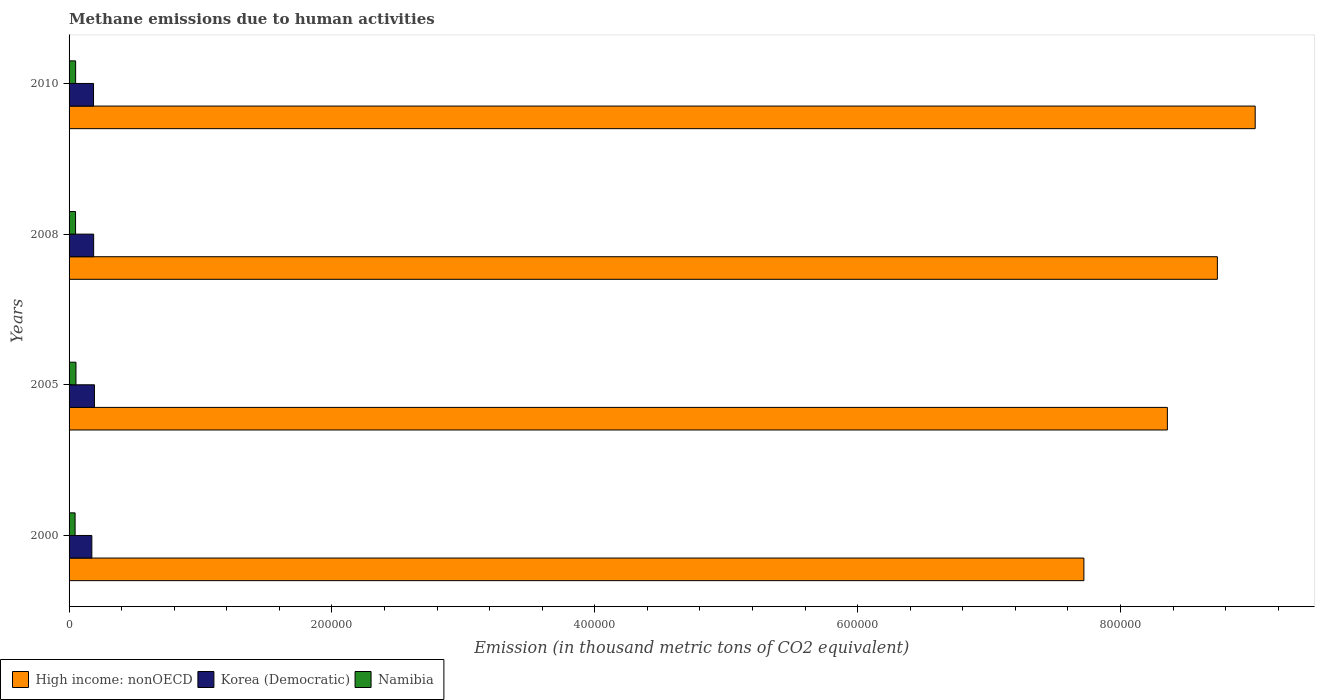Are the number of bars per tick equal to the number of legend labels?
Make the answer very short. Yes. What is the label of the 1st group of bars from the top?
Ensure brevity in your answer.  2010. In how many cases, is the number of bars for a given year not equal to the number of legend labels?
Ensure brevity in your answer.  0. What is the amount of methane emitted in Namibia in 2005?
Offer a very short reply. 5251.3. Across all years, what is the maximum amount of methane emitted in Korea (Democratic)?
Ensure brevity in your answer.  1.93e+04. Across all years, what is the minimum amount of methane emitted in High income: nonOECD?
Ensure brevity in your answer.  7.72e+05. In which year was the amount of methane emitted in Korea (Democratic) minimum?
Provide a short and direct response. 2000. What is the total amount of methane emitted in Korea (Democratic) in the graph?
Give a very brief answer. 7.39e+04. What is the difference between the amount of methane emitted in Korea (Democratic) in 2000 and that in 2010?
Offer a terse response. -1287.4. What is the difference between the amount of methane emitted in High income: nonOECD in 2000 and the amount of methane emitted in Namibia in 2008?
Make the answer very short. 7.67e+05. What is the average amount of methane emitted in Namibia per year?
Provide a succinct answer. 4940.77. In the year 2008, what is the difference between the amount of methane emitted in Korea (Democratic) and amount of methane emitted in Namibia?
Your answer should be very brief. 1.38e+04. What is the ratio of the amount of methane emitted in Korea (Democratic) in 2008 to that in 2010?
Ensure brevity in your answer.  1.01. Is the difference between the amount of methane emitted in Korea (Democratic) in 2000 and 2005 greater than the difference between the amount of methane emitted in Namibia in 2000 and 2005?
Provide a succinct answer. No. What is the difference between the highest and the second highest amount of methane emitted in Korea (Democratic)?
Your answer should be very brief. 596.3. What is the difference between the highest and the lowest amount of methane emitted in Namibia?
Give a very brief answer. 669.6. In how many years, is the amount of methane emitted in Namibia greater than the average amount of methane emitted in Namibia taken over all years?
Offer a terse response. 3. What does the 2nd bar from the top in 2005 represents?
Give a very brief answer. Korea (Democratic). What does the 2nd bar from the bottom in 2000 represents?
Give a very brief answer. Korea (Democratic). How many bars are there?
Offer a very short reply. 12. How many years are there in the graph?
Offer a terse response. 4. What is the difference between two consecutive major ticks on the X-axis?
Your response must be concise. 2.00e+05. Are the values on the major ticks of X-axis written in scientific E-notation?
Keep it short and to the point. No. Does the graph contain any zero values?
Provide a succinct answer. No. Does the graph contain grids?
Give a very brief answer. No. How many legend labels are there?
Offer a terse response. 3. What is the title of the graph?
Your response must be concise. Methane emissions due to human activities. Does "Colombia" appear as one of the legend labels in the graph?
Keep it short and to the point. No. What is the label or title of the X-axis?
Keep it short and to the point. Emission (in thousand metric tons of CO2 equivalent). What is the Emission (in thousand metric tons of CO2 equivalent) of High income: nonOECD in 2000?
Offer a very short reply. 7.72e+05. What is the Emission (in thousand metric tons of CO2 equivalent) in Korea (Democratic) in 2000?
Make the answer very short. 1.73e+04. What is the Emission (in thousand metric tons of CO2 equivalent) of Namibia in 2000?
Your answer should be very brief. 4581.7. What is the Emission (in thousand metric tons of CO2 equivalent) of High income: nonOECD in 2005?
Make the answer very short. 8.36e+05. What is the Emission (in thousand metric tons of CO2 equivalent) of Korea (Democratic) in 2005?
Make the answer very short. 1.93e+04. What is the Emission (in thousand metric tons of CO2 equivalent) of Namibia in 2005?
Your answer should be very brief. 5251.3. What is the Emission (in thousand metric tons of CO2 equivalent) of High income: nonOECD in 2008?
Provide a succinct answer. 8.74e+05. What is the Emission (in thousand metric tons of CO2 equivalent) in Korea (Democratic) in 2008?
Your answer should be very brief. 1.87e+04. What is the Emission (in thousand metric tons of CO2 equivalent) of Namibia in 2008?
Make the answer very short. 4941.9. What is the Emission (in thousand metric tons of CO2 equivalent) in High income: nonOECD in 2010?
Provide a succinct answer. 9.02e+05. What is the Emission (in thousand metric tons of CO2 equivalent) in Korea (Democratic) in 2010?
Provide a short and direct response. 1.86e+04. What is the Emission (in thousand metric tons of CO2 equivalent) in Namibia in 2010?
Your answer should be compact. 4988.2. Across all years, what is the maximum Emission (in thousand metric tons of CO2 equivalent) in High income: nonOECD?
Offer a terse response. 9.02e+05. Across all years, what is the maximum Emission (in thousand metric tons of CO2 equivalent) of Korea (Democratic)?
Provide a succinct answer. 1.93e+04. Across all years, what is the maximum Emission (in thousand metric tons of CO2 equivalent) of Namibia?
Your answer should be very brief. 5251.3. Across all years, what is the minimum Emission (in thousand metric tons of CO2 equivalent) in High income: nonOECD?
Your answer should be compact. 7.72e+05. Across all years, what is the minimum Emission (in thousand metric tons of CO2 equivalent) in Korea (Democratic)?
Your response must be concise. 1.73e+04. Across all years, what is the minimum Emission (in thousand metric tons of CO2 equivalent) of Namibia?
Your answer should be compact. 4581.7. What is the total Emission (in thousand metric tons of CO2 equivalent) of High income: nonOECD in the graph?
Provide a succinct answer. 3.38e+06. What is the total Emission (in thousand metric tons of CO2 equivalent) of Korea (Democratic) in the graph?
Provide a succinct answer. 7.39e+04. What is the total Emission (in thousand metric tons of CO2 equivalent) of Namibia in the graph?
Offer a terse response. 1.98e+04. What is the difference between the Emission (in thousand metric tons of CO2 equivalent) of High income: nonOECD in 2000 and that in 2005?
Your answer should be very brief. -6.35e+04. What is the difference between the Emission (in thousand metric tons of CO2 equivalent) of Korea (Democratic) in 2000 and that in 2005?
Your answer should be compact. -1977. What is the difference between the Emission (in thousand metric tons of CO2 equivalent) in Namibia in 2000 and that in 2005?
Your answer should be compact. -669.6. What is the difference between the Emission (in thousand metric tons of CO2 equivalent) of High income: nonOECD in 2000 and that in 2008?
Ensure brevity in your answer.  -1.02e+05. What is the difference between the Emission (in thousand metric tons of CO2 equivalent) of Korea (Democratic) in 2000 and that in 2008?
Your answer should be compact. -1380.7. What is the difference between the Emission (in thousand metric tons of CO2 equivalent) in Namibia in 2000 and that in 2008?
Your response must be concise. -360.2. What is the difference between the Emission (in thousand metric tons of CO2 equivalent) of High income: nonOECD in 2000 and that in 2010?
Your answer should be very brief. -1.30e+05. What is the difference between the Emission (in thousand metric tons of CO2 equivalent) of Korea (Democratic) in 2000 and that in 2010?
Make the answer very short. -1287.4. What is the difference between the Emission (in thousand metric tons of CO2 equivalent) in Namibia in 2000 and that in 2010?
Make the answer very short. -406.5. What is the difference between the Emission (in thousand metric tons of CO2 equivalent) in High income: nonOECD in 2005 and that in 2008?
Provide a succinct answer. -3.80e+04. What is the difference between the Emission (in thousand metric tons of CO2 equivalent) in Korea (Democratic) in 2005 and that in 2008?
Ensure brevity in your answer.  596.3. What is the difference between the Emission (in thousand metric tons of CO2 equivalent) in Namibia in 2005 and that in 2008?
Your response must be concise. 309.4. What is the difference between the Emission (in thousand metric tons of CO2 equivalent) of High income: nonOECD in 2005 and that in 2010?
Your answer should be very brief. -6.68e+04. What is the difference between the Emission (in thousand metric tons of CO2 equivalent) of Korea (Democratic) in 2005 and that in 2010?
Provide a short and direct response. 689.6. What is the difference between the Emission (in thousand metric tons of CO2 equivalent) in Namibia in 2005 and that in 2010?
Make the answer very short. 263.1. What is the difference between the Emission (in thousand metric tons of CO2 equivalent) in High income: nonOECD in 2008 and that in 2010?
Ensure brevity in your answer.  -2.88e+04. What is the difference between the Emission (in thousand metric tons of CO2 equivalent) in Korea (Democratic) in 2008 and that in 2010?
Your response must be concise. 93.3. What is the difference between the Emission (in thousand metric tons of CO2 equivalent) in Namibia in 2008 and that in 2010?
Provide a succinct answer. -46.3. What is the difference between the Emission (in thousand metric tons of CO2 equivalent) in High income: nonOECD in 2000 and the Emission (in thousand metric tons of CO2 equivalent) in Korea (Democratic) in 2005?
Ensure brevity in your answer.  7.53e+05. What is the difference between the Emission (in thousand metric tons of CO2 equivalent) in High income: nonOECD in 2000 and the Emission (in thousand metric tons of CO2 equivalent) in Namibia in 2005?
Your answer should be very brief. 7.67e+05. What is the difference between the Emission (in thousand metric tons of CO2 equivalent) in Korea (Democratic) in 2000 and the Emission (in thousand metric tons of CO2 equivalent) in Namibia in 2005?
Offer a terse response. 1.21e+04. What is the difference between the Emission (in thousand metric tons of CO2 equivalent) of High income: nonOECD in 2000 and the Emission (in thousand metric tons of CO2 equivalent) of Korea (Democratic) in 2008?
Your response must be concise. 7.53e+05. What is the difference between the Emission (in thousand metric tons of CO2 equivalent) in High income: nonOECD in 2000 and the Emission (in thousand metric tons of CO2 equivalent) in Namibia in 2008?
Provide a short and direct response. 7.67e+05. What is the difference between the Emission (in thousand metric tons of CO2 equivalent) in Korea (Democratic) in 2000 and the Emission (in thousand metric tons of CO2 equivalent) in Namibia in 2008?
Your response must be concise. 1.24e+04. What is the difference between the Emission (in thousand metric tons of CO2 equivalent) of High income: nonOECD in 2000 and the Emission (in thousand metric tons of CO2 equivalent) of Korea (Democratic) in 2010?
Your answer should be compact. 7.54e+05. What is the difference between the Emission (in thousand metric tons of CO2 equivalent) in High income: nonOECD in 2000 and the Emission (in thousand metric tons of CO2 equivalent) in Namibia in 2010?
Offer a terse response. 7.67e+05. What is the difference between the Emission (in thousand metric tons of CO2 equivalent) of Korea (Democratic) in 2000 and the Emission (in thousand metric tons of CO2 equivalent) of Namibia in 2010?
Make the answer very short. 1.23e+04. What is the difference between the Emission (in thousand metric tons of CO2 equivalent) of High income: nonOECD in 2005 and the Emission (in thousand metric tons of CO2 equivalent) of Korea (Democratic) in 2008?
Keep it short and to the point. 8.17e+05. What is the difference between the Emission (in thousand metric tons of CO2 equivalent) in High income: nonOECD in 2005 and the Emission (in thousand metric tons of CO2 equivalent) in Namibia in 2008?
Make the answer very short. 8.31e+05. What is the difference between the Emission (in thousand metric tons of CO2 equivalent) in Korea (Democratic) in 2005 and the Emission (in thousand metric tons of CO2 equivalent) in Namibia in 2008?
Keep it short and to the point. 1.44e+04. What is the difference between the Emission (in thousand metric tons of CO2 equivalent) in High income: nonOECD in 2005 and the Emission (in thousand metric tons of CO2 equivalent) in Korea (Democratic) in 2010?
Keep it short and to the point. 8.17e+05. What is the difference between the Emission (in thousand metric tons of CO2 equivalent) in High income: nonOECD in 2005 and the Emission (in thousand metric tons of CO2 equivalent) in Namibia in 2010?
Your answer should be very brief. 8.31e+05. What is the difference between the Emission (in thousand metric tons of CO2 equivalent) of Korea (Democratic) in 2005 and the Emission (in thousand metric tons of CO2 equivalent) of Namibia in 2010?
Your answer should be very brief. 1.43e+04. What is the difference between the Emission (in thousand metric tons of CO2 equivalent) in High income: nonOECD in 2008 and the Emission (in thousand metric tons of CO2 equivalent) in Korea (Democratic) in 2010?
Provide a short and direct response. 8.55e+05. What is the difference between the Emission (in thousand metric tons of CO2 equivalent) in High income: nonOECD in 2008 and the Emission (in thousand metric tons of CO2 equivalent) in Namibia in 2010?
Offer a very short reply. 8.69e+05. What is the difference between the Emission (in thousand metric tons of CO2 equivalent) of Korea (Democratic) in 2008 and the Emission (in thousand metric tons of CO2 equivalent) of Namibia in 2010?
Your response must be concise. 1.37e+04. What is the average Emission (in thousand metric tons of CO2 equivalent) in High income: nonOECD per year?
Provide a short and direct response. 8.46e+05. What is the average Emission (in thousand metric tons of CO2 equivalent) in Korea (Democratic) per year?
Keep it short and to the point. 1.85e+04. What is the average Emission (in thousand metric tons of CO2 equivalent) in Namibia per year?
Provide a short and direct response. 4940.77. In the year 2000, what is the difference between the Emission (in thousand metric tons of CO2 equivalent) of High income: nonOECD and Emission (in thousand metric tons of CO2 equivalent) of Korea (Democratic)?
Make the answer very short. 7.55e+05. In the year 2000, what is the difference between the Emission (in thousand metric tons of CO2 equivalent) in High income: nonOECD and Emission (in thousand metric tons of CO2 equivalent) in Namibia?
Your response must be concise. 7.68e+05. In the year 2000, what is the difference between the Emission (in thousand metric tons of CO2 equivalent) of Korea (Democratic) and Emission (in thousand metric tons of CO2 equivalent) of Namibia?
Provide a short and direct response. 1.27e+04. In the year 2005, what is the difference between the Emission (in thousand metric tons of CO2 equivalent) of High income: nonOECD and Emission (in thousand metric tons of CO2 equivalent) of Korea (Democratic)?
Make the answer very short. 8.16e+05. In the year 2005, what is the difference between the Emission (in thousand metric tons of CO2 equivalent) of High income: nonOECD and Emission (in thousand metric tons of CO2 equivalent) of Namibia?
Provide a succinct answer. 8.30e+05. In the year 2005, what is the difference between the Emission (in thousand metric tons of CO2 equivalent) of Korea (Democratic) and Emission (in thousand metric tons of CO2 equivalent) of Namibia?
Offer a terse response. 1.40e+04. In the year 2008, what is the difference between the Emission (in thousand metric tons of CO2 equivalent) of High income: nonOECD and Emission (in thousand metric tons of CO2 equivalent) of Korea (Democratic)?
Ensure brevity in your answer.  8.55e+05. In the year 2008, what is the difference between the Emission (in thousand metric tons of CO2 equivalent) of High income: nonOECD and Emission (in thousand metric tons of CO2 equivalent) of Namibia?
Keep it short and to the point. 8.69e+05. In the year 2008, what is the difference between the Emission (in thousand metric tons of CO2 equivalent) of Korea (Democratic) and Emission (in thousand metric tons of CO2 equivalent) of Namibia?
Ensure brevity in your answer.  1.38e+04. In the year 2010, what is the difference between the Emission (in thousand metric tons of CO2 equivalent) in High income: nonOECD and Emission (in thousand metric tons of CO2 equivalent) in Korea (Democratic)?
Your response must be concise. 8.84e+05. In the year 2010, what is the difference between the Emission (in thousand metric tons of CO2 equivalent) in High income: nonOECD and Emission (in thousand metric tons of CO2 equivalent) in Namibia?
Offer a very short reply. 8.97e+05. In the year 2010, what is the difference between the Emission (in thousand metric tons of CO2 equivalent) of Korea (Democratic) and Emission (in thousand metric tons of CO2 equivalent) of Namibia?
Your response must be concise. 1.36e+04. What is the ratio of the Emission (in thousand metric tons of CO2 equivalent) of High income: nonOECD in 2000 to that in 2005?
Your answer should be very brief. 0.92. What is the ratio of the Emission (in thousand metric tons of CO2 equivalent) of Korea (Democratic) in 2000 to that in 2005?
Make the answer very short. 0.9. What is the ratio of the Emission (in thousand metric tons of CO2 equivalent) of Namibia in 2000 to that in 2005?
Give a very brief answer. 0.87. What is the ratio of the Emission (in thousand metric tons of CO2 equivalent) of High income: nonOECD in 2000 to that in 2008?
Provide a short and direct response. 0.88. What is the ratio of the Emission (in thousand metric tons of CO2 equivalent) in Korea (Democratic) in 2000 to that in 2008?
Provide a succinct answer. 0.93. What is the ratio of the Emission (in thousand metric tons of CO2 equivalent) in Namibia in 2000 to that in 2008?
Make the answer very short. 0.93. What is the ratio of the Emission (in thousand metric tons of CO2 equivalent) of High income: nonOECD in 2000 to that in 2010?
Offer a very short reply. 0.86. What is the ratio of the Emission (in thousand metric tons of CO2 equivalent) of Korea (Democratic) in 2000 to that in 2010?
Your answer should be very brief. 0.93. What is the ratio of the Emission (in thousand metric tons of CO2 equivalent) of Namibia in 2000 to that in 2010?
Keep it short and to the point. 0.92. What is the ratio of the Emission (in thousand metric tons of CO2 equivalent) in High income: nonOECD in 2005 to that in 2008?
Offer a terse response. 0.96. What is the ratio of the Emission (in thousand metric tons of CO2 equivalent) in Korea (Democratic) in 2005 to that in 2008?
Ensure brevity in your answer.  1.03. What is the ratio of the Emission (in thousand metric tons of CO2 equivalent) in Namibia in 2005 to that in 2008?
Your answer should be very brief. 1.06. What is the ratio of the Emission (in thousand metric tons of CO2 equivalent) in High income: nonOECD in 2005 to that in 2010?
Keep it short and to the point. 0.93. What is the ratio of the Emission (in thousand metric tons of CO2 equivalent) in Korea (Democratic) in 2005 to that in 2010?
Make the answer very short. 1.04. What is the ratio of the Emission (in thousand metric tons of CO2 equivalent) of Namibia in 2005 to that in 2010?
Your answer should be very brief. 1.05. What is the ratio of the Emission (in thousand metric tons of CO2 equivalent) in High income: nonOECD in 2008 to that in 2010?
Provide a succinct answer. 0.97. What is the difference between the highest and the second highest Emission (in thousand metric tons of CO2 equivalent) of High income: nonOECD?
Your answer should be very brief. 2.88e+04. What is the difference between the highest and the second highest Emission (in thousand metric tons of CO2 equivalent) in Korea (Democratic)?
Make the answer very short. 596.3. What is the difference between the highest and the second highest Emission (in thousand metric tons of CO2 equivalent) of Namibia?
Give a very brief answer. 263.1. What is the difference between the highest and the lowest Emission (in thousand metric tons of CO2 equivalent) of High income: nonOECD?
Your answer should be compact. 1.30e+05. What is the difference between the highest and the lowest Emission (in thousand metric tons of CO2 equivalent) of Korea (Democratic)?
Your answer should be very brief. 1977. What is the difference between the highest and the lowest Emission (in thousand metric tons of CO2 equivalent) of Namibia?
Give a very brief answer. 669.6. 